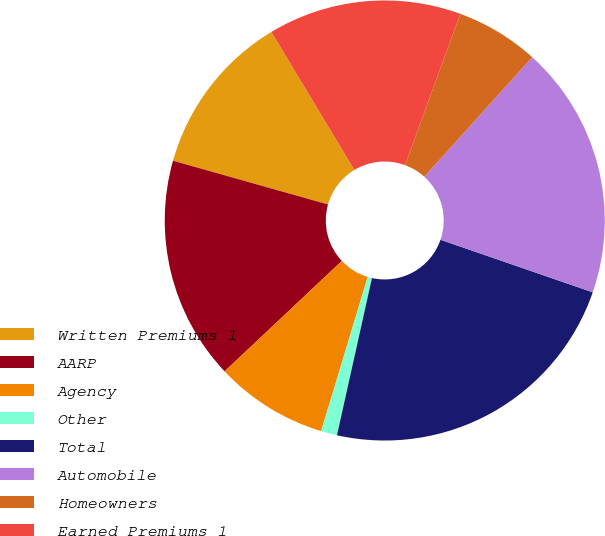Convert chart. <chart><loc_0><loc_0><loc_500><loc_500><pie_chart><fcel>Written Premiums 1<fcel>AARP<fcel>Agency<fcel>Other<fcel>Total<fcel>Automobile<fcel>Homeowners<fcel>Earned Premiums 1<nl><fcel>12.0%<fcel>16.4%<fcel>8.31%<fcel>1.18%<fcel>23.19%<fcel>18.6%<fcel>6.11%<fcel>14.2%<nl></chart> 